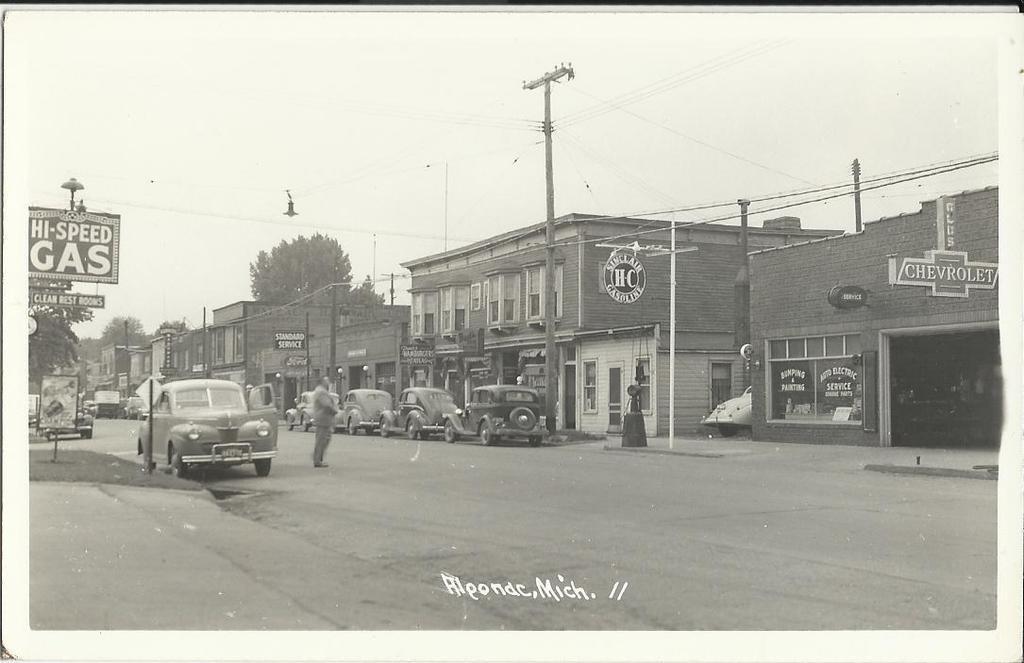Could you give a brief overview of what you see in this image? In this picture I can see the road in front and in the middle of this picture I see number of buildings, trees, poles, wires, cars and I see a person and I see number of boards on which there is something written. In the background I see the sky and I see that this is a black and white picture. 